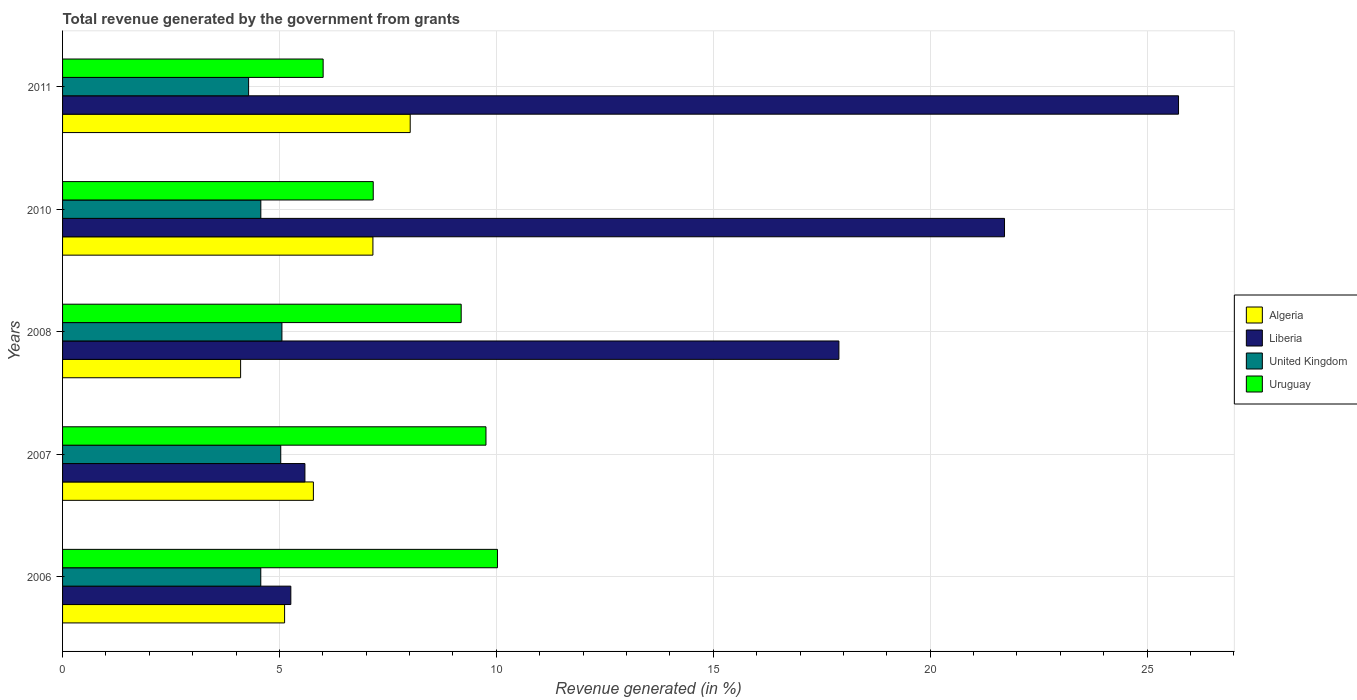Are the number of bars per tick equal to the number of legend labels?
Provide a short and direct response. Yes. What is the total revenue generated in Algeria in 2011?
Offer a very short reply. 8.01. Across all years, what is the maximum total revenue generated in Uruguay?
Give a very brief answer. 10.03. Across all years, what is the minimum total revenue generated in United Kingdom?
Your answer should be compact. 4.29. In which year was the total revenue generated in Uruguay minimum?
Offer a terse response. 2011. What is the total total revenue generated in United Kingdom in the graph?
Provide a short and direct response. 23.52. What is the difference between the total revenue generated in United Kingdom in 2006 and that in 2011?
Provide a short and direct response. 0.28. What is the difference between the total revenue generated in Liberia in 2006 and the total revenue generated in Algeria in 2008?
Your response must be concise. 1.16. What is the average total revenue generated in Uruguay per year?
Ensure brevity in your answer.  8.43. In the year 2011, what is the difference between the total revenue generated in Liberia and total revenue generated in Algeria?
Provide a succinct answer. 17.71. In how many years, is the total revenue generated in United Kingdom greater than 19 %?
Ensure brevity in your answer.  0. What is the ratio of the total revenue generated in United Kingdom in 2006 to that in 2011?
Ensure brevity in your answer.  1.07. Is the total revenue generated in Algeria in 2007 less than that in 2011?
Keep it short and to the point. Yes. Is the difference between the total revenue generated in Liberia in 2007 and 2008 greater than the difference between the total revenue generated in Algeria in 2007 and 2008?
Your answer should be very brief. No. What is the difference between the highest and the second highest total revenue generated in Algeria?
Offer a terse response. 0.86. What is the difference between the highest and the lowest total revenue generated in Liberia?
Offer a terse response. 20.46. Is the sum of the total revenue generated in Uruguay in 2008 and 2011 greater than the maximum total revenue generated in Algeria across all years?
Offer a terse response. Yes. Is it the case that in every year, the sum of the total revenue generated in Liberia and total revenue generated in Uruguay is greater than the sum of total revenue generated in United Kingdom and total revenue generated in Algeria?
Give a very brief answer. Yes. What does the 3rd bar from the top in 2011 represents?
Make the answer very short. Liberia. What does the 1st bar from the bottom in 2011 represents?
Ensure brevity in your answer.  Algeria. How many years are there in the graph?
Give a very brief answer. 5. What is the difference between two consecutive major ticks on the X-axis?
Provide a short and direct response. 5. Does the graph contain any zero values?
Provide a short and direct response. No. How many legend labels are there?
Offer a very short reply. 4. How are the legend labels stacked?
Provide a succinct answer. Vertical. What is the title of the graph?
Your answer should be compact. Total revenue generated by the government from grants. Does "Aruba" appear as one of the legend labels in the graph?
Keep it short and to the point. No. What is the label or title of the X-axis?
Your answer should be compact. Revenue generated (in %). What is the label or title of the Y-axis?
Offer a terse response. Years. What is the Revenue generated (in %) in Algeria in 2006?
Provide a succinct answer. 5.12. What is the Revenue generated (in %) in Liberia in 2006?
Provide a succinct answer. 5.26. What is the Revenue generated (in %) in United Kingdom in 2006?
Give a very brief answer. 4.57. What is the Revenue generated (in %) in Uruguay in 2006?
Offer a terse response. 10.03. What is the Revenue generated (in %) of Algeria in 2007?
Your response must be concise. 5.78. What is the Revenue generated (in %) in Liberia in 2007?
Provide a short and direct response. 5.59. What is the Revenue generated (in %) in United Kingdom in 2007?
Provide a short and direct response. 5.03. What is the Revenue generated (in %) in Uruguay in 2007?
Ensure brevity in your answer.  9.76. What is the Revenue generated (in %) of Algeria in 2008?
Offer a very short reply. 4.1. What is the Revenue generated (in %) in Liberia in 2008?
Give a very brief answer. 17.9. What is the Revenue generated (in %) of United Kingdom in 2008?
Offer a terse response. 5.06. What is the Revenue generated (in %) of Uruguay in 2008?
Ensure brevity in your answer.  9.19. What is the Revenue generated (in %) in Algeria in 2010?
Offer a very short reply. 7.15. What is the Revenue generated (in %) of Liberia in 2010?
Make the answer very short. 21.71. What is the Revenue generated (in %) in United Kingdom in 2010?
Keep it short and to the point. 4.57. What is the Revenue generated (in %) in Uruguay in 2010?
Make the answer very short. 7.16. What is the Revenue generated (in %) of Algeria in 2011?
Your answer should be compact. 8.01. What is the Revenue generated (in %) of Liberia in 2011?
Your response must be concise. 25.73. What is the Revenue generated (in %) in United Kingdom in 2011?
Provide a succinct answer. 4.29. What is the Revenue generated (in %) in Uruguay in 2011?
Keep it short and to the point. 6.01. Across all years, what is the maximum Revenue generated (in %) of Algeria?
Your response must be concise. 8.01. Across all years, what is the maximum Revenue generated (in %) of Liberia?
Provide a succinct answer. 25.73. Across all years, what is the maximum Revenue generated (in %) in United Kingdom?
Offer a terse response. 5.06. Across all years, what is the maximum Revenue generated (in %) of Uruguay?
Give a very brief answer. 10.03. Across all years, what is the minimum Revenue generated (in %) in Algeria?
Provide a short and direct response. 4.1. Across all years, what is the minimum Revenue generated (in %) of Liberia?
Your response must be concise. 5.26. Across all years, what is the minimum Revenue generated (in %) in United Kingdom?
Your response must be concise. 4.29. Across all years, what is the minimum Revenue generated (in %) of Uruguay?
Give a very brief answer. 6.01. What is the total Revenue generated (in %) in Algeria in the graph?
Offer a terse response. 30.17. What is the total Revenue generated (in %) of Liberia in the graph?
Provide a short and direct response. 76.19. What is the total Revenue generated (in %) in United Kingdom in the graph?
Offer a very short reply. 23.52. What is the total Revenue generated (in %) in Uruguay in the graph?
Provide a succinct answer. 42.14. What is the difference between the Revenue generated (in %) of Algeria in 2006 and that in 2007?
Your response must be concise. -0.66. What is the difference between the Revenue generated (in %) of Liberia in 2006 and that in 2007?
Offer a very short reply. -0.33. What is the difference between the Revenue generated (in %) in United Kingdom in 2006 and that in 2007?
Provide a short and direct response. -0.46. What is the difference between the Revenue generated (in %) in Uruguay in 2006 and that in 2007?
Provide a succinct answer. 0.27. What is the difference between the Revenue generated (in %) of Algeria in 2006 and that in 2008?
Give a very brief answer. 1.01. What is the difference between the Revenue generated (in %) of Liberia in 2006 and that in 2008?
Your answer should be compact. -12.63. What is the difference between the Revenue generated (in %) of United Kingdom in 2006 and that in 2008?
Make the answer very short. -0.49. What is the difference between the Revenue generated (in %) of Uruguay in 2006 and that in 2008?
Provide a succinct answer. 0.84. What is the difference between the Revenue generated (in %) of Algeria in 2006 and that in 2010?
Ensure brevity in your answer.  -2.04. What is the difference between the Revenue generated (in %) of Liberia in 2006 and that in 2010?
Give a very brief answer. -16.45. What is the difference between the Revenue generated (in %) in United Kingdom in 2006 and that in 2010?
Provide a succinct answer. -0. What is the difference between the Revenue generated (in %) in Uruguay in 2006 and that in 2010?
Make the answer very short. 2.86. What is the difference between the Revenue generated (in %) in Algeria in 2006 and that in 2011?
Offer a terse response. -2.9. What is the difference between the Revenue generated (in %) of Liberia in 2006 and that in 2011?
Keep it short and to the point. -20.46. What is the difference between the Revenue generated (in %) of United Kingdom in 2006 and that in 2011?
Ensure brevity in your answer.  0.28. What is the difference between the Revenue generated (in %) of Uruguay in 2006 and that in 2011?
Your answer should be very brief. 4.02. What is the difference between the Revenue generated (in %) of Algeria in 2007 and that in 2008?
Provide a succinct answer. 1.68. What is the difference between the Revenue generated (in %) in Liberia in 2007 and that in 2008?
Offer a very short reply. -12.31. What is the difference between the Revenue generated (in %) in United Kingdom in 2007 and that in 2008?
Give a very brief answer. -0.03. What is the difference between the Revenue generated (in %) in Uruguay in 2007 and that in 2008?
Ensure brevity in your answer.  0.57. What is the difference between the Revenue generated (in %) of Algeria in 2007 and that in 2010?
Provide a short and direct response. -1.37. What is the difference between the Revenue generated (in %) of Liberia in 2007 and that in 2010?
Make the answer very short. -16.13. What is the difference between the Revenue generated (in %) of United Kingdom in 2007 and that in 2010?
Your answer should be very brief. 0.46. What is the difference between the Revenue generated (in %) of Uruguay in 2007 and that in 2010?
Give a very brief answer. 2.6. What is the difference between the Revenue generated (in %) of Algeria in 2007 and that in 2011?
Your answer should be compact. -2.23. What is the difference between the Revenue generated (in %) of Liberia in 2007 and that in 2011?
Offer a very short reply. -20.14. What is the difference between the Revenue generated (in %) of United Kingdom in 2007 and that in 2011?
Your answer should be very brief. 0.74. What is the difference between the Revenue generated (in %) in Uruguay in 2007 and that in 2011?
Give a very brief answer. 3.75. What is the difference between the Revenue generated (in %) in Algeria in 2008 and that in 2010?
Your response must be concise. -3.05. What is the difference between the Revenue generated (in %) of Liberia in 2008 and that in 2010?
Ensure brevity in your answer.  -3.82. What is the difference between the Revenue generated (in %) in United Kingdom in 2008 and that in 2010?
Give a very brief answer. 0.49. What is the difference between the Revenue generated (in %) in Uruguay in 2008 and that in 2010?
Make the answer very short. 2.03. What is the difference between the Revenue generated (in %) of Algeria in 2008 and that in 2011?
Your answer should be compact. -3.91. What is the difference between the Revenue generated (in %) of Liberia in 2008 and that in 2011?
Keep it short and to the point. -7.83. What is the difference between the Revenue generated (in %) of United Kingdom in 2008 and that in 2011?
Offer a terse response. 0.77. What is the difference between the Revenue generated (in %) of Uruguay in 2008 and that in 2011?
Offer a terse response. 3.18. What is the difference between the Revenue generated (in %) of Algeria in 2010 and that in 2011?
Your answer should be very brief. -0.86. What is the difference between the Revenue generated (in %) of Liberia in 2010 and that in 2011?
Your response must be concise. -4.01. What is the difference between the Revenue generated (in %) in United Kingdom in 2010 and that in 2011?
Keep it short and to the point. 0.28. What is the difference between the Revenue generated (in %) of Uruguay in 2010 and that in 2011?
Keep it short and to the point. 1.15. What is the difference between the Revenue generated (in %) of Algeria in 2006 and the Revenue generated (in %) of Liberia in 2007?
Give a very brief answer. -0.47. What is the difference between the Revenue generated (in %) in Algeria in 2006 and the Revenue generated (in %) in United Kingdom in 2007?
Provide a short and direct response. 0.09. What is the difference between the Revenue generated (in %) of Algeria in 2006 and the Revenue generated (in %) of Uruguay in 2007?
Keep it short and to the point. -4.64. What is the difference between the Revenue generated (in %) in Liberia in 2006 and the Revenue generated (in %) in United Kingdom in 2007?
Offer a terse response. 0.23. What is the difference between the Revenue generated (in %) in Liberia in 2006 and the Revenue generated (in %) in Uruguay in 2007?
Your response must be concise. -4.5. What is the difference between the Revenue generated (in %) in United Kingdom in 2006 and the Revenue generated (in %) in Uruguay in 2007?
Offer a terse response. -5.19. What is the difference between the Revenue generated (in %) in Algeria in 2006 and the Revenue generated (in %) in Liberia in 2008?
Offer a very short reply. -12.78. What is the difference between the Revenue generated (in %) of Algeria in 2006 and the Revenue generated (in %) of United Kingdom in 2008?
Your answer should be very brief. 0.06. What is the difference between the Revenue generated (in %) of Algeria in 2006 and the Revenue generated (in %) of Uruguay in 2008?
Provide a short and direct response. -4.07. What is the difference between the Revenue generated (in %) in Liberia in 2006 and the Revenue generated (in %) in United Kingdom in 2008?
Ensure brevity in your answer.  0.21. What is the difference between the Revenue generated (in %) in Liberia in 2006 and the Revenue generated (in %) in Uruguay in 2008?
Give a very brief answer. -3.93. What is the difference between the Revenue generated (in %) in United Kingdom in 2006 and the Revenue generated (in %) in Uruguay in 2008?
Make the answer very short. -4.62. What is the difference between the Revenue generated (in %) in Algeria in 2006 and the Revenue generated (in %) in Liberia in 2010?
Offer a very short reply. -16.6. What is the difference between the Revenue generated (in %) of Algeria in 2006 and the Revenue generated (in %) of United Kingdom in 2010?
Your answer should be compact. 0.55. What is the difference between the Revenue generated (in %) in Algeria in 2006 and the Revenue generated (in %) in Uruguay in 2010?
Offer a terse response. -2.04. What is the difference between the Revenue generated (in %) in Liberia in 2006 and the Revenue generated (in %) in United Kingdom in 2010?
Ensure brevity in your answer.  0.69. What is the difference between the Revenue generated (in %) in Liberia in 2006 and the Revenue generated (in %) in Uruguay in 2010?
Your answer should be very brief. -1.9. What is the difference between the Revenue generated (in %) in United Kingdom in 2006 and the Revenue generated (in %) in Uruguay in 2010?
Offer a very short reply. -2.59. What is the difference between the Revenue generated (in %) of Algeria in 2006 and the Revenue generated (in %) of Liberia in 2011?
Make the answer very short. -20.61. What is the difference between the Revenue generated (in %) of Algeria in 2006 and the Revenue generated (in %) of United Kingdom in 2011?
Ensure brevity in your answer.  0.83. What is the difference between the Revenue generated (in %) in Algeria in 2006 and the Revenue generated (in %) in Uruguay in 2011?
Make the answer very short. -0.89. What is the difference between the Revenue generated (in %) of Liberia in 2006 and the Revenue generated (in %) of United Kingdom in 2011?
Your response must be concise. 0.97. What is the difference between the Revenue generated (in %) of Liberia in 2006 and the Revenue generated (in %) of Uruguay in 2011?
Give a very brief answer. -0.75. What is the difference between the Revenue generated (in %) in United Kingdom in 2006 and the Revenue generated (in %) in Uruguay in 2011?
Your response must be concise. -1.44. What is the difference between the Revenue generated (in %) in Algeria in 2007 and the Revenue generated (in %) in Liberia in 2008?
Your answer should be compact. -12.11. What is the difference between the Revenue generated (in %) of Algeria in 2007 and the Revenue generated (in %) of United Kingdom in 2008?
Offer a terse response. 0.73. What is the difference between the Revenue generated (in %) of Algeria in 2007 and the Revenue generated (in %) of Uruguay in 2008?
Provide a succinct answer. -3.41. What is the difference between the Revenue generated (in %) in Liberia in 2007 and the Revenue generated (in %) in United Kingdom in 2008?
Your answer should be compact. 0.53. What is the difference between the Revenue generated (in %) of Liberia in 2007 and the Revenue generated (in %) of Uruguay in 2008?
Ensure brevity in your answer.  -3.6. What is the difference between the Revenue generated (in %) in United Kingdom in 2007 and the Revenue generated (in %) in Uruguay in 2008?
Give a very brief answer. -4.16. What is the difference between the Revenue generated (in %) of Algeria in 2007 and the Revenue generated (in %) of Liberia in 2010?
Give a very brief answer. -15.93. What is the difference between the Revenue generated (in %) of Algeria in 2007 and the Revenue generated (in %) of United Kingdom in 2010?
Offer a terse response. 1.21. What is the difference between the Revenue generated (in %) in Algeria in 2007 and the Revenue generated (in %) in Uruguay in 2010?
Your answer should be compact. -1.38. What is the difference between the Revenue generated (in %) of Liberia in 2007 and the Revenue generated (in %) of United Kingdom in 2010?
Provide a succinct answer. 1.02. What is the difference between the Revenue generated (in %) of Liberia in 2007 and the Revenue generated (in %) of Uruguay in 2010?
Your answer should be compact. -1.57. What is the difference between the Revenue generated (in %) of United Kingdom in 2007 and the Revenue generated (in %) of Uruguay in 2010?
Your answer should be compact. -2.13. What is the difference between the Revenue generated (in %) of Algeria in 2007 and the Revenue generated (in %) of Liberia in 2011?
Make the answer very short. -19.94. What is the difference between the Revenue generated (in %) of Algeria in 2007 and the Revenue generated (in %) of United Kingdom in 2011?
Keep it short and to the point. 1.49. What is the difference between the Revenue generated (in %) of Algeria in 2007 and the Revenue generated (in %) of Uruguay in 2011?
Offer a very short reply. -0.22. What is the difference between the Revenue generated (in %) of Liberia in 2007 and the Revenue generated (in %) of United Kingdom in 2011?
Keep it short and to the point. 1.3. What is the difference between the Revenue generated (in %) in Liberia in 2007 and the Revenue generated (in %) in Uruguay in 2011?
Your response must be concise. -0.42. What is the difference between the Revenue generated (in %) of United Kingdom in 2007 and the Revenue generated (in %) of Uruguay in 2011?
Offer a very short reply. -0.98. What is the difference between the Revenue generated (in %) in Algeria in 2008 and the Revenue generated (in %) in Liberia in 2010?
Your answer should be very brief. -17.61. What is the difference between the Revenue generated (in %) in Algeria in 2008 and the Revenue generated (in %) in United Kingdom in 2010?
Your response must be concise. -0.47. What is the difference between the Revenue generated (in %) in Algeria in 2008 and the Revenue generated (in %) in Uruguay in 2010?
Offer a very short reply. -3.06. What is the difference between the Revenue generated (in %) of Liberia in 2008 and the Revenue generated (in %) of United Kingdom in 2010?
Offer a very short reply. 13.33. What is the difference between the Revenue generated (in %) of Liberia in 2008 and the Revenue generated (in %) of Uruguay in 2010?
Offer a very short reply. 10.73. What is the difference between the Revenue generated (in %) in United Kingdom in 2008 and the Revenue generated (in %) in Uruguay in 2010?
Your response must be concise. -2.1. What is the difference between the Revenue generated (in %) in Algeria in 2008 and the Revenue generated (in %) in Liberia in 2011?
Offer a terse response. -21.62. What is the difference between the Revenue generated (in %) in Algeria in 2008 and the Revenue generated (in %) in United Kingdom in 2011?
Your answer should be very brief. -0.18. What is the difference between the Revenue generated (in %) in Algeria in 2008 and the Revenue generated (in %) in Uruguay in 2011?
Give a very brief answer. -1.9. What is the difference between the Revenue generated (in %) in Liberia in 2008 and the Revenue generated (in %) in United Kingdom in 2011?
Give a very brief answer. 13.61. What is the difference between the Revenue generated (in %) in Liberia in 2008 and the Revenue generated (in %) in Uruguay in 2011?
Make the answer very short. 11.89. What is the difference between the Revenue generated (in %) in United Kingdom in 2008 and the Revenue generated (in %) in Uruguay in 2011?
Offer a terse response. -0.95. What is the difference between the Revenue generated (in %) of Algeria in 2010 and the Revenue generated (in %) of Liberia in 2011?
Give a very brief answer. -18.57. What is the difference between the Revenue generated (in %) in Algeria in 2010 and the Revenue generated (in %) in United Kingdom in 2011?
Give a very brief answer. 2.87. What is the difference between the Revenue generated (in %) of Algeria in 2010 and the Revenue generated (in %) of Uruguay in 2011?
Your answer should be very brief. 1.15. What is the difference between the Revenue generated (in %) in Liberia in 2010 and the Revenue generated (in %) in United Kingdom in 2011?
Keep it short and to the point. 17.43. What is the difference between the Revenue generated (in %) of Liberia in 2010 and the Revenue generated (in %) of Uruguay in 2011?
Your response must be concise. 15.71. What is the difference between the Revenue generated (in %) in United Kingdom in 2010 and the Revenue generated (in %) in Uruguay in 2011?
Offer a very short reply. -1.44. What is the average Revenue generated (in %) of Algeria per year?
Your response must be concise. 6.03. What is the average Revenue generated (in %) in Liberia per year?
Give a very brief answer. 15.24. What is the average Revenue generated (in %) in United Kingdom per year?
Give a very brief answer. 4.7. What is the average Revenue generated (in %) in Uruguay per year?
Your response must be concise. 8.43. In the year 2006, what is the difference between the Revenue generated (in %) of Algeria and Revenue generated (in %) of Liberia?
Your answer should be very brief. -0.14. In the year 2006, what is the difference between the Revenue generated (in %) of Algeria and Revenue generated (in %) of United Kingdom?
Offer a terse response. 0.55. In the year 2006, what is the difference between the Revenue generated (in %) of Algeria and Revenue generated (in %) of Uruguay?
Offer a very short reply. -4.91. In the year 2006, what is the difference between the Revenue generated (in %) in Liberia and Revenue generated (in %) in United Kingdom?
Keep it short and to the point. 0.69. In the year 2006, what is the difference between the Revenue generated (in %) of Liberia and Revenue generated (in %) of Uruguay?
Offer a terse response. -4.76. In the year 2006, what is the difference between the Revenue generated (in %) in United Kingdom and Revenue generated (in %) in Uruguay?
Keep it short and to the point. -5.46. In the year 2007, what is the difference between the Revenue generated (in %) of Algeria and Revenue generated (in %) of Liberia?
Give a very brief answer. 0.2. In the year 2007, what is the difference between the Revenue generated (in %) of Algeria and Revenue generated (in %) of United Kingdom?
Your answer should be compact. 0.75. In the year 2007, what is the difference between the Revenue generated (in %) of Algeria and Revenue generated (in %) of Uruguay?
Give a very brief answer. -3.98. In the year 2007, what is the difference between the Revenue generated (in %) in Liberia and Revenue generated (in %) in United Kingdom?
Your answer should be compact. 0.56. In the year 2007, what is the difference between the Revenue generated (in %) in Liberia and Revenue generated (in %) in Uruguay?
Keep it short and to the point. -4.17. In the year 2007, what is the difference between the Revenue generated (in %) of United Kingdom and Revenue generated (in %) of Uruguay?
Your answer should be very brief. -4.73. In the year 2008, what is the difference between the Revenue generated (in %) in Algeria and Revenue generated (in %) in Liberia?
Your answer should be very brief. -13.79. In the year 2008, what is the difference between the Revenue generated (in %) of Algeria and Revenue generated (in %) of United Kingdom?
Ensure brevity in your answer.  -0.95. In the year 2008, what is the difference between the Revenue generated (in %) in Algeria and Revenue generated (in %) in Uruguay?
Your response must be concise. -5.09. In the year 2008, what is the difference between the Revenue generated (in %) of Liberia and Revenue generated (in %) of United Kingdom?
Make the answer very short. 12.84. In the year 2008, what is the difference between the Revenue generated (in %) in Liberia and Revenue generated (in %) in Uruguay?
Your answer should be compact. 8.71. In the year 2008, what is the difference between the Revenue generated (in %) in United Kingdom and Revenue generated (in %) in Uruguay?
Provide a short and direct response. -4.13. In the year 2010, what is the difference between the Revenue generated (in %) in Algeria and Revenue generated (in %) in Liberia?
Offer a very short reply. -14.56. In the year 2010, what is the difference between the Revenue generated (in %) of Algeria and Revenue generated (in %) of United Kingdom?
Your response must be concise. 2.58. In the year 2010, what is the difference between the Revenue generated (in %) in Algeria and Revenue generated (in %) in Uruguay?
Provide a short and direct response. -0.01. In the year 2010, what is the difference between the Revenue generated (in %) in Liberia and Revenue generated (in %) in United Kingdom?
Offer a terse response. 17.14. In the year 2010, what is the difference between the Revenue generated (in %) in Liberia and Revenue generated (in %) in Uruguay?
Keep it short and to the point. 14.55. In the year 2010, what is the difference between the Revenue generated (in %) of United Kingdom and Revenue generated (in %) of Uruguay?
Provide a succinct answer. -2.59. In the year 2011, what is the difference between the Revenue generated (in %) of Algeria and Revenue generated (in %) of Liberia?
Provide a short and direct response. -17.71. In the year 2011, what is the difference between the Revenue generated (in %) in Algeria and Revenue generated (in %) in United Kingdom?
Offer a terse response. 3.73. In the year 2011, what is the difference between the Revenue generated (in %) in Algeria and Revenue generated (in %) in Uruguay?
Your response must be concise. 2.01. In the year 2011, what is the difference between the Revenue generated (in %) of Liberia and Revenue generated (in %) of United Kingdom?
Keep it short and to the point. 21.44. In the year 2011, what is the difference between the Revenue generated (in %) of Liberia and Revenue generated (in %) of Uruguay?
Offer a terse response. 19.72. In the year 2011, what is the difference between the Revenue generated (in %) of United Kingdom and Revenue generated (in %) of Uruguay?
Provide a succinct answer. -1.72. What is the ratio of the Revenue generated (in %) of Algeria in 2006 to that in 2007?
Provide a succinct answer. 0.89. What is the ratio of the Revenue generated (in %) in Liberia in 2006 to that in 2007?
Provide a short and direct response. 0.94. What is the ratio of the Revenue generated (in %) in United Kingdom in 2006 to that in 2007?
Make the answer very short. 0.91. What is the ratio of the Revenue generated (in %) of Uruguay in 2006 to that in 2007?
Provide a short and direct response. 1.03. What is the ratio of the Revenue generated (in %) of Algeria in 2006 to that in 2008?
Provide a short and direct response. 1.25. What is the ratio of the Revenue generated (in %) in Liberia in 2006 to that in 2008?
Your answer should be very brief. 0.29. What is the ratio of the Revenue generated (in %) of United Kingdom in 2006 to that in 2008?
Your answer should be very brief. 0.9. What is the ratio of the Revenue generated (in %) in Uruguay in 2006 to that in 2008?
Provide a succinct answer. 1.09. What is the ratio of the Revenue generated (in %) in Algeria in 2006 to that in 2010?
Make the answer very short. 0.72. What is the ratio of the Revenue generated (in %) in Liberia in 2006 to that in 2010?
Ensure brevity in your answer.  0.24. What is the ratio of the Revenue generated (in %) in United Kingdom in 2006 to that in 2010?
Provide a short and direct response. 1. What is the ratio of the Revenue generated (in %) of Uruguay in 2006 to that in 2010?
Provide a short and direct response. 1.4. What is the ratio of the Revenue generated (in %) in Algeria in 2006 to that in 2011?
Provide a succinct answer. 0.64. What is the ratio of the Revenue generated (in %) of Liberia in 2006 to that in 2011?
Your response must be concise. 0.2. What is the ratio of the Revenue generated (in %) in United Kingdom in 2006 to that in 2011?
Provide a short and direct response. 1.07. What is the ratio of the Revenue generated (in %) of Uruguay in 2006 to that in 2011?
Offer a terse response. 1.67. What is the ratio of the Revenue generated (in %) of Algeria in 2007 to that in 2008?
Your response must be concise. 1.41. What is the ratio of the Revenue generated (in %) of Liberia in 2007 to that in 2008?
Make the answer very short. 0.31. What is the ratio of the Revenue generated (in %) in United Kingdom in 2007 to that in 2008?
Make the answer very short. 0.99. What is the ratio of the Revenue generated (in %) of Uruguay in 2007 to that in 2008?
Offer a very short reply. 1.06. What is the ratio of the Revenue generated (in %) in Algeria in 2007 to that in 2010?
Your answer should be very brief. 0.81. What is the ratio of the Revenue generated (in %) in Liberia in 2007 to that in 2010?
Provide a short and direct response. 0.26. What is the ratio of the Revenue generated (in %) in United Kingdom in 2007 to that in 2010?
Your answer should be compact. 1.1. What is the ratio of the Revenue generated (in %) of Uruguay in 2007 to that in 2010?
Give a very brief answer. 1.36. What is the ratio of the Revenue generated (in %) in Algeria in 2007 to that in 2011?
Give a very brief answer. 0.72. What is the ratio of the Revenue generated (in %) in Liberia in 2007 to that in 2011?
Offer a terse response. 0.22. What is the ratio of the Revenue generated (in %) of United Kingdom in 2007 to that in 2011?
Make the answer very short. 1.17. What is the ratio of the Revenue generated (in %) of Uruguay in 2007 to that in 2011?
Provide a short and direct response. 1.62. What is the ratio of the Revenue generated (in %) of Algeria in 2008 to that in 2010?
Provide a succinct answer. 0.57. What is the ratio of the Revenue generated (in %) in Liberia in 2008 to that in 2010?
Offer a terse response. 0.82. What is the ratio of the Revenue generated (in %) of United Kingdom in 2008 to that in 2010?
Your answer should be very brief. 1.11. What is the ratio of the Revenue generated (in %) of Uruguay in 2008 to that in 2010?
Make the answer very short. 1.28. What is the ratio of the Revenue generated (in %) of Algeria in 2008 to that in 2011?
Provide a short and direct response. 0.51. What is the ratio of the Revenue generated (in %) of Liberia in 2008 to that in 2011?
Give a very brief answer. 0.7. What is the ratio of the Revenue generated (in %) in United Kingdom in 2008 to that in 2011?
Your answer should be compact. 1.18. What is the ratio of the Revenue generated (in %) in Uruguay in 2008 to that in 2011?
Your answer should be very brief. 1.53. What is the ratio of the Revenue generated (in %) in Algeria in 2010 to that in 2011?
Keep it short and to the point. 0.89. What is the ratio of the Revenue generated (in %) of Liberia in 2010 to that in 2011?
Provide a short and direct response. 0.84. What is the ratio of the Revenue generated (in %) in United Kingdom in 2010 to that in 2011?
Offer a terse response. 1.07. What is the ratio of the Revenue generated (in %) in Uruguay in 2010 to that in 2011?
Provide a succinct answer. 1.19. What is the difference between the highest and the second highest Revenue generated (in %) in Algeria?
Give a very brief answer. 0.86. What is the difference between the highest and the second highest Revenue generated (in %) in Liberia?
Give a very brief answer. 4.01. What is the difference between the highest and the second highest Revenue generated (in %) of United Kingdom?
Provide a short and direct response. 0.03. What is the difference between the highest and the second highest Revenue generated (in %) in Uruguay?
Your answer should be compact. 0.27. What is the difference between the highest and the lowest Revenue generated (in %) in Algeria?
Give a very brief answer. 3.91. What is the difference between the highest and the lowest Revenue generated (in %) of Liberia?
Your answer should be compact. 20.46. What is the difference between the highest and the lowest Revenue generated (in %) in United Kingdom?
Ensure brevity in your answer.  0.77. What is the difference between the highest and the lowest Revenue generated (in %) in Uruguay?
Your answer should be compact. 4.02. 